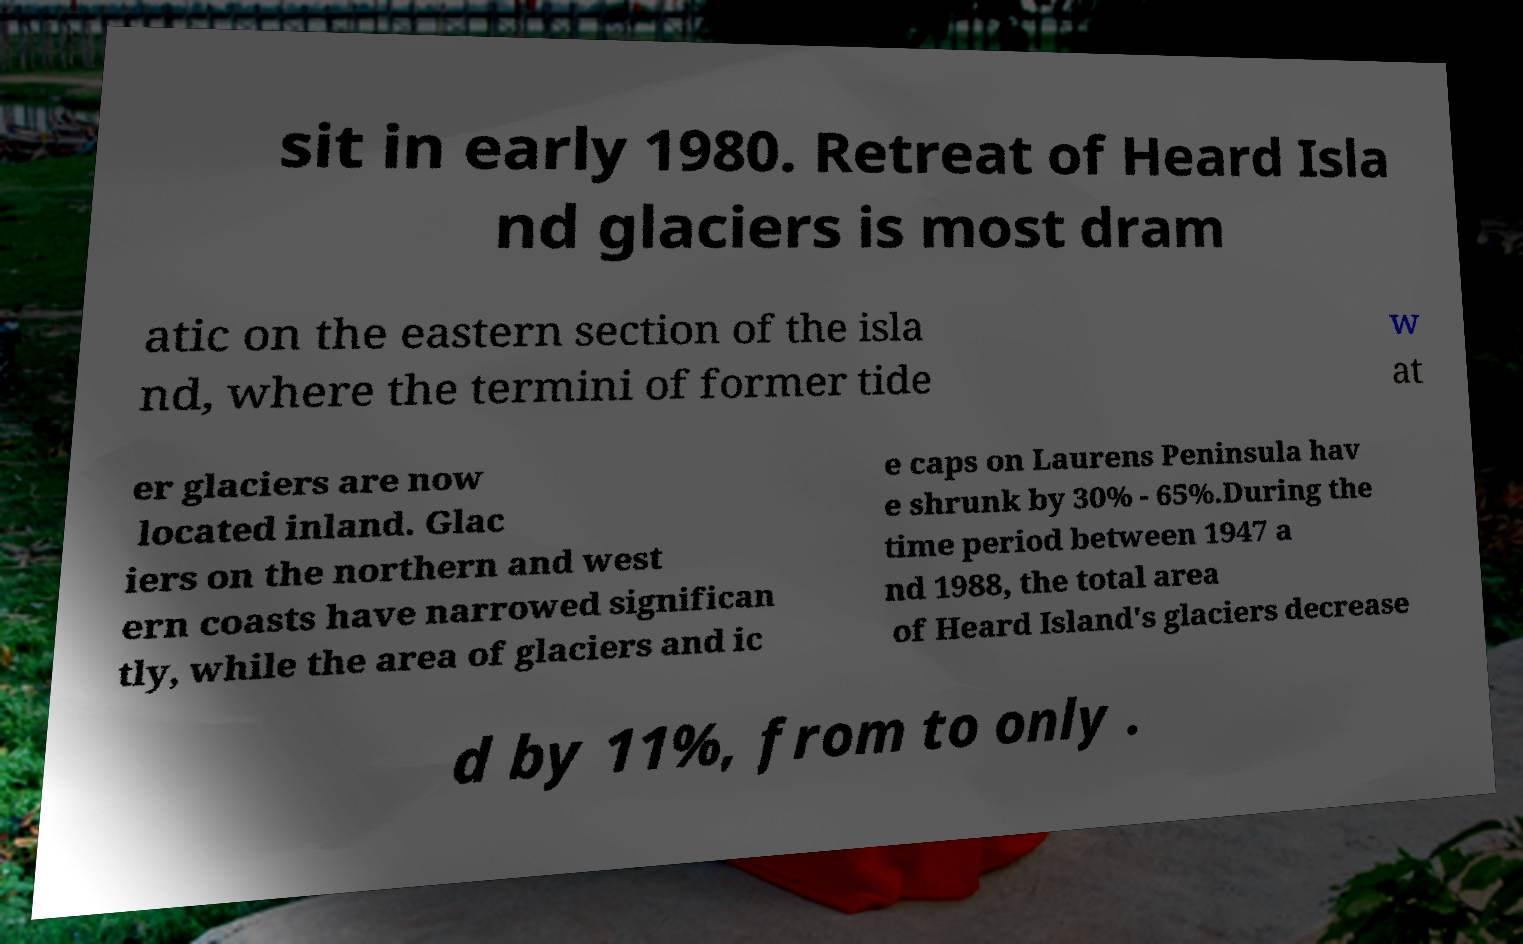For documentation purposes, I need the text within this image transcribed. Could you provide that? sit in early 1980. Retreat of Heard Isla nd glaciers is most dram atic on the eastern section of the isla nd, where the termini of former tide w at er glaciers are now located inland. Glac iers on the northern and west ern coasts have narrowed significan tly, while the area of glaciers and ic e caps on Laurens Peninsula hav e shrunk by 30% - 65%.During the time period between 1947 a nd 1988, the total area of Heard Island's glaciers decrease d by 11%, from to only . 